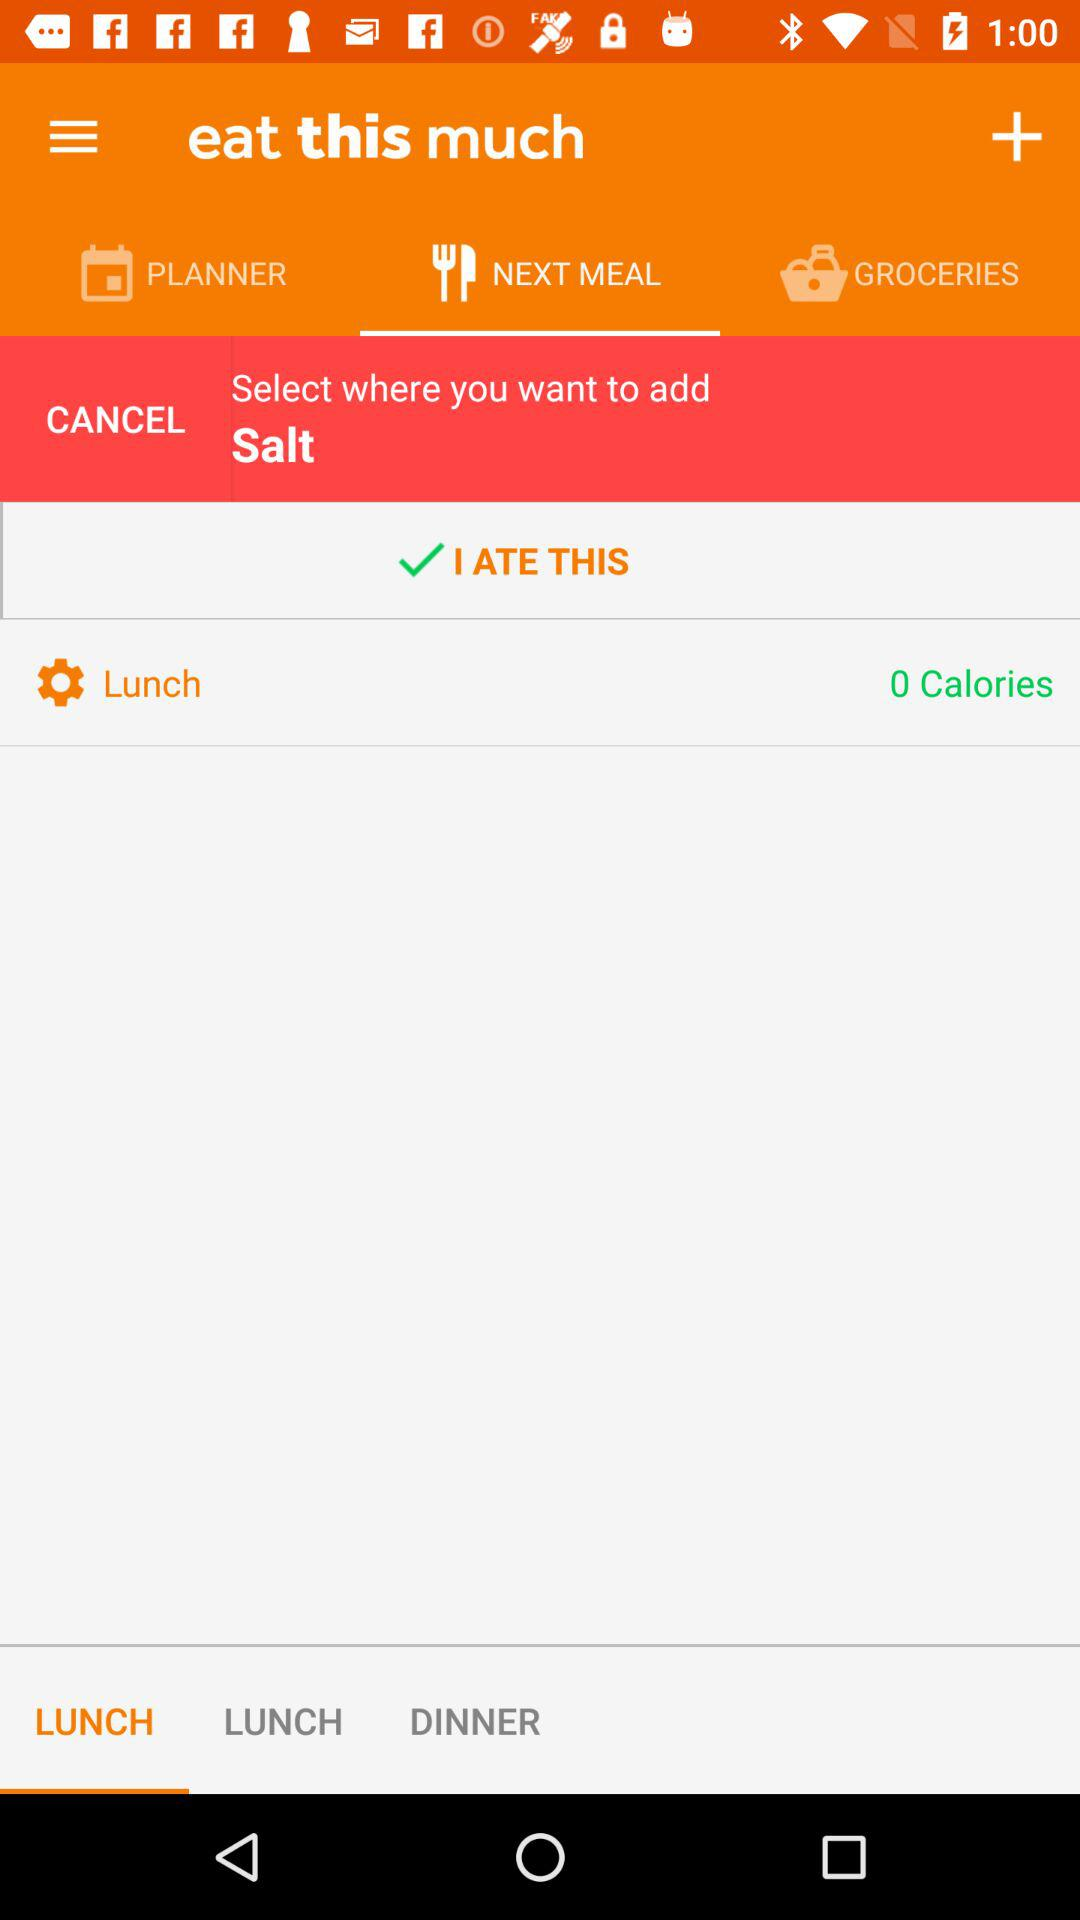How many calories does the user want to eat?
Answer the question using a single word or phrase. 0 